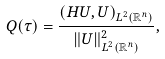<formula> <loc_0><loc_0><loc_500><loc_500>Q ( \tau ) = \frac { ( H U , U ) _ { L ^ { 2 } ( { \mathbb { R } ^ { n } } ) } } { \| U \| ^ { 2 } _ { L ^ { 2 } ( { \mathbb { R } ^ { n } } ) } } ,</formula> 